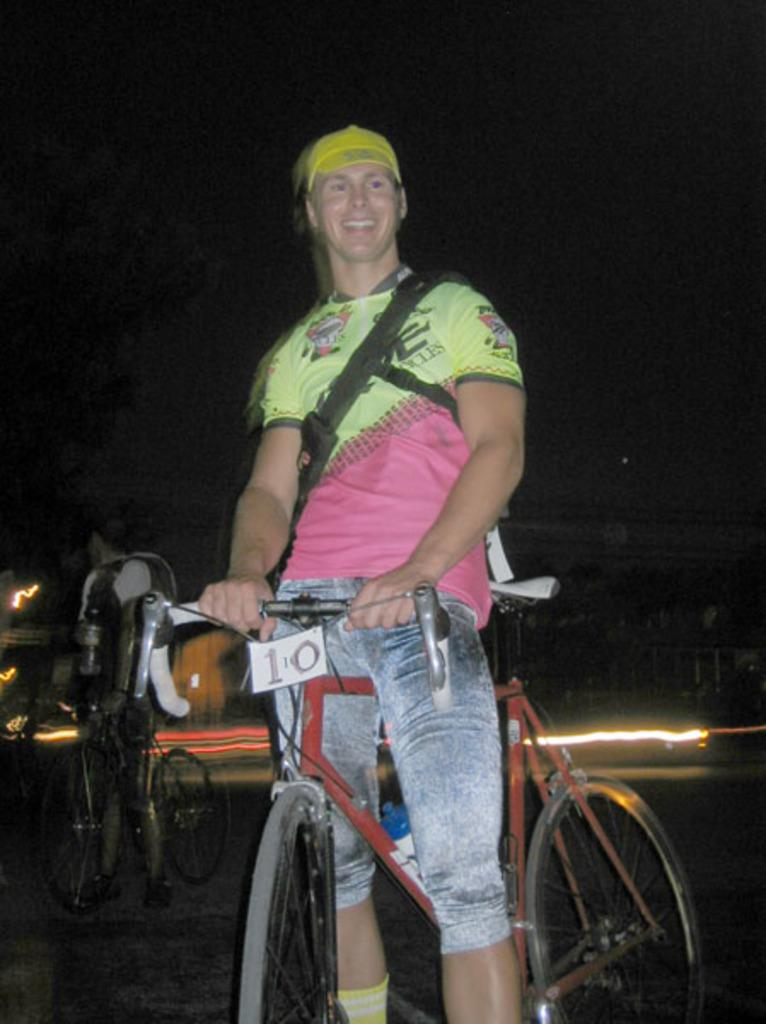What is the main subject of the image? There is a person standing in the image. What is the person holding in the image? The person is holding a bicycle. What can be seen in the background of the image? The background includes light and a bicycle. What type of calculator is the person using while standing with the bicycle in the image? There is no calculator present in the image; the person is simply holding a bicycle. 